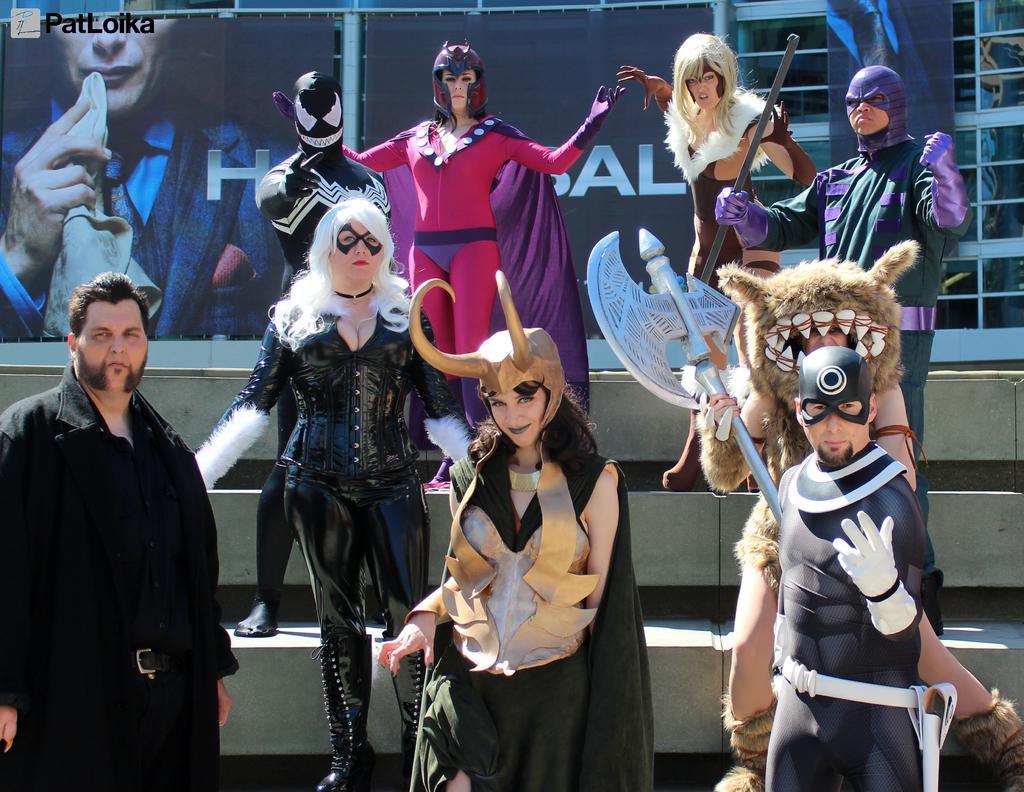In one or two sentences, can you explain what this image depicts? In this image we can see a group of people wearing costume are standing on the staircase, some are holding weapons in their hands. In the background, we can see banners with picture and some text and some metal frames. 